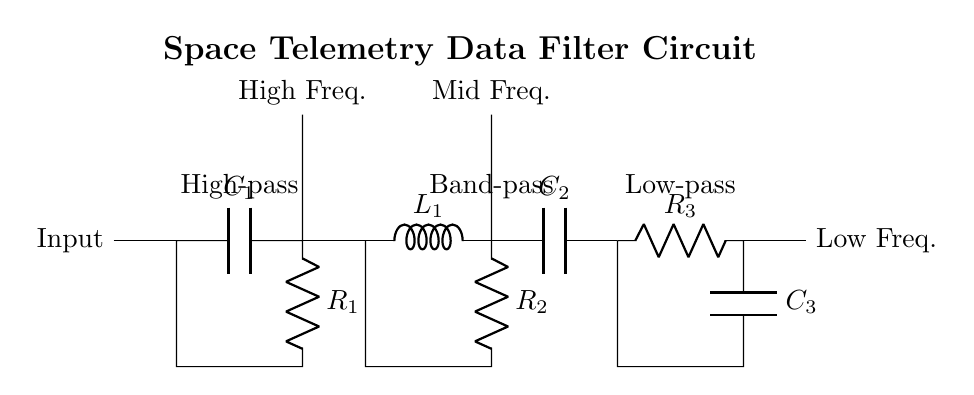What type of filter is between the input and the band-pass filter? The circuit starts with a high-pass filter that is located directly after the input line. This is shown by the capacitor and resistor connected in series before the signal continues into the band-pass filter.
Answer: High-pass What components are used in the low-pass filter? The low-pass filter is made up of a resistor and a capacitor connected in series, which can be found toward the end of the circuit diagram. The values are labeled as R3 for the resistor and C3 for the capacitor.
Answer: Resistor and capacitor What is the frequency range output of the band-pass filter? The band-pass filter selectively allows a range of frequencies, outputting the mid-frequency signal as designated in the diagram. The output is connected above this filter, indicating the intermediate frequency response.
Answer: Mid frequency How many types of filters are present in this circuit? The circuit has three distinct filter types: high-pass, band-pass, and low-pass, as indicated by the labels placed above each filter section in the diagram.
Answer: Three What does the output labeled "High Freq." correspond to in the circuit? The output labeled "High Freq." is directly connected to the output of the high-pass filter, which allows frequencies higher than a certain cutoff frequency to pass through while attenuating lower frequencies.
Answer: High frequencies Which component is connected to the output labeled "Low Freq."? The output determined as "Low Freq." is connected to the low-pass filter's output, which consists of a resistor and capacitor and allows low frequencies to pass while blocking higher frequencies.
Answer: Resistor and capacitor 